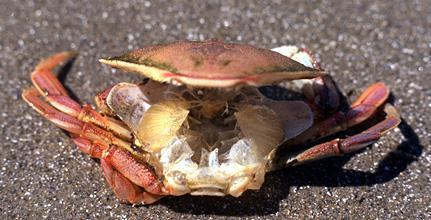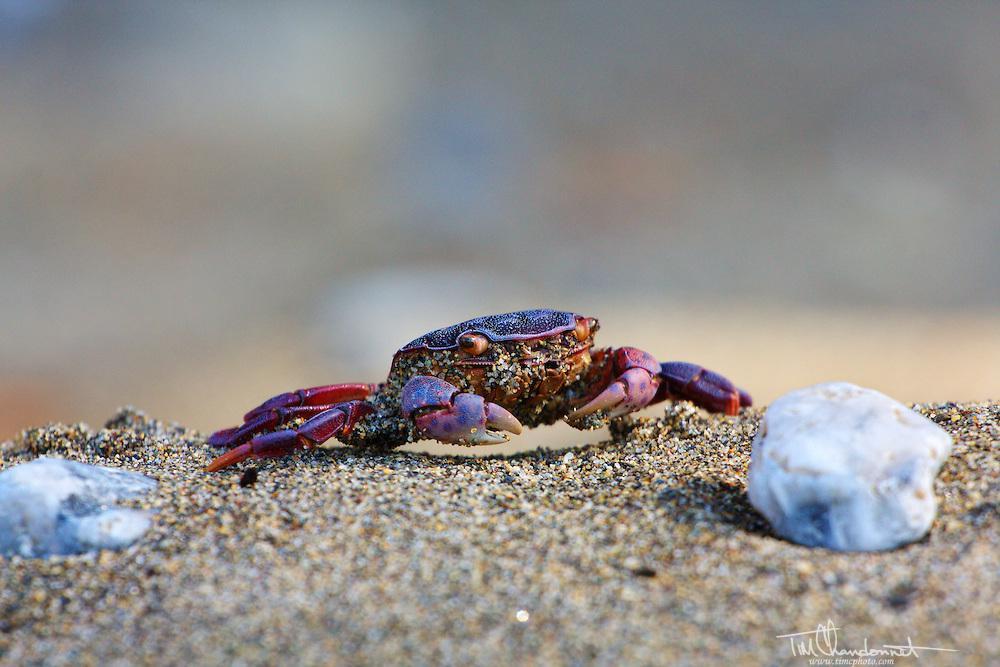The first image is the image on the left, the second image is the image on the right. Evaluate the accuracy of this statement regarding the images: "The left and right image contains the same number of crabs in the sand.". Is it true? Answer yes or no. Yes. 